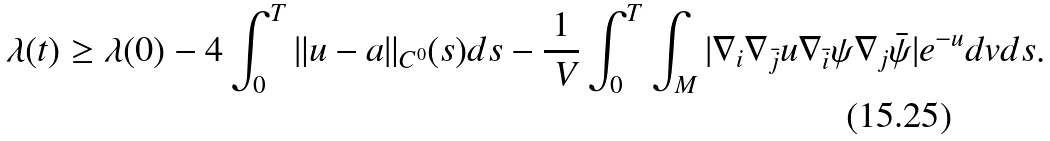Convert formula to latex. <formula><loc_0><loc_0><loc_500><loc_500>\lambda ( t ) \geq \lambda ( 0 ) - 4 \int _ { 0 } ^ { T } \| u - a \| _ { C ^ { 0 } } ( s ) d s - \frac { 1 } { \ V } \int _ { 0 } ^ { T } \int _ { M } | \nabla _ { i } \nabla _ { \bar { j } } u \nabla _ { \bar { i } } \psi \nabla _ { j } \bar { \psi } | e ^ { - u } d v d s .</formula> 